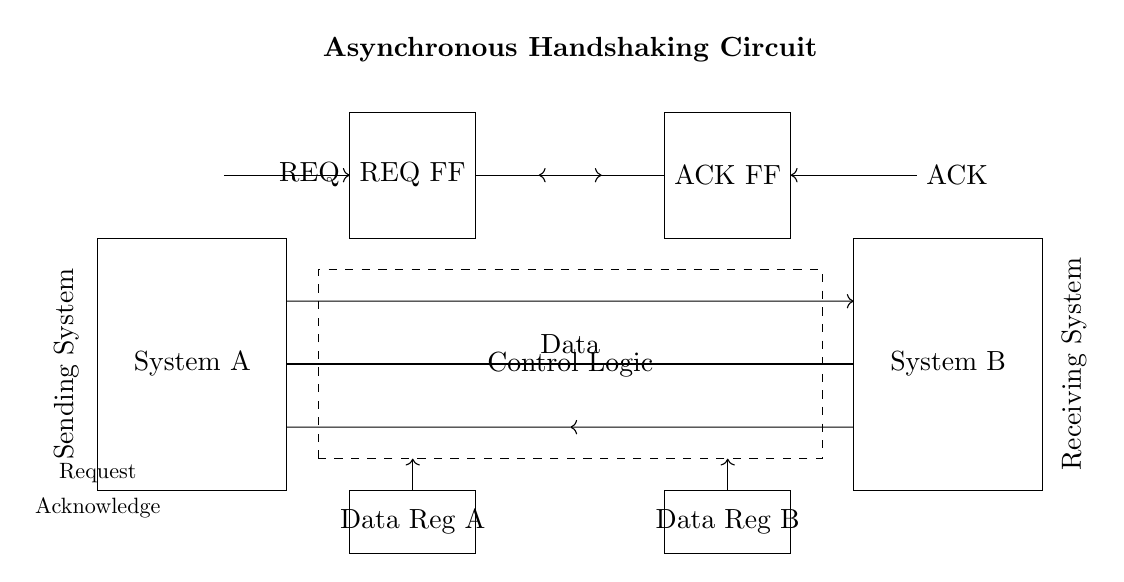What does the dashed box represent? The dashed box represents the control logic that manages the signal transfer between the systems and the flip-flops. It coordinates the request and acknowledgment signals to ensure proper timing in the data exchange.
Answer: Control Logic What signals are used for handshaking in this circuit? The signals used for handshaking are the Request and Acknowledge signals. The Request signal is sent from System A to System B to initiate the transfer, and the Acknowledge signal is sent back to confirm receipt of the data.
Answer: Request and Acknowledge How many flip-flops are shown in the circuit? There are two flip-flops in the circuit, one for the Request signal and one for the Acknowledge signal, which store the states of these signals during the handshaking process.
Answer: 2 What is the function of the data registers in the circuit? The data registers temporarily hold the data being transferred between System A and System B until the transfer is acknowledged. They ensure data integrity during the communication process.
Answer: Hold data Which component sends the Request signal? The component that sends the Request signal is the Request flip-flop, which gets triggered by the REQ input from System A to initiate the handshaking process.
Answer: REQ FF Why is asynchronous handshaking preferred over synchronous handshaking? Asynchronous handshaking is preferred because it allows data transfer without a shared clock, making it more flexible and efficient for systems that may operate at different frequencies or timing.
Answer: Flexibility 